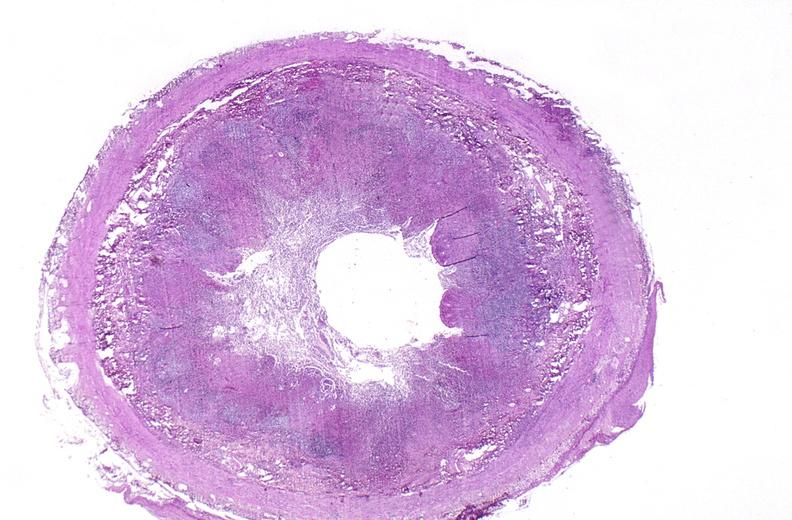what does this image show?
Answer the question using a single word or phrase. Appendix 